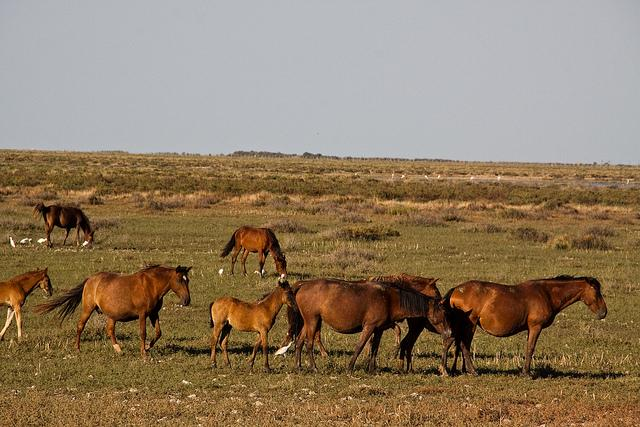What type of land are the horses found on? Please explain your reasoning. plains. A bunch of horses are walking on a large, open, flat piece of land. 